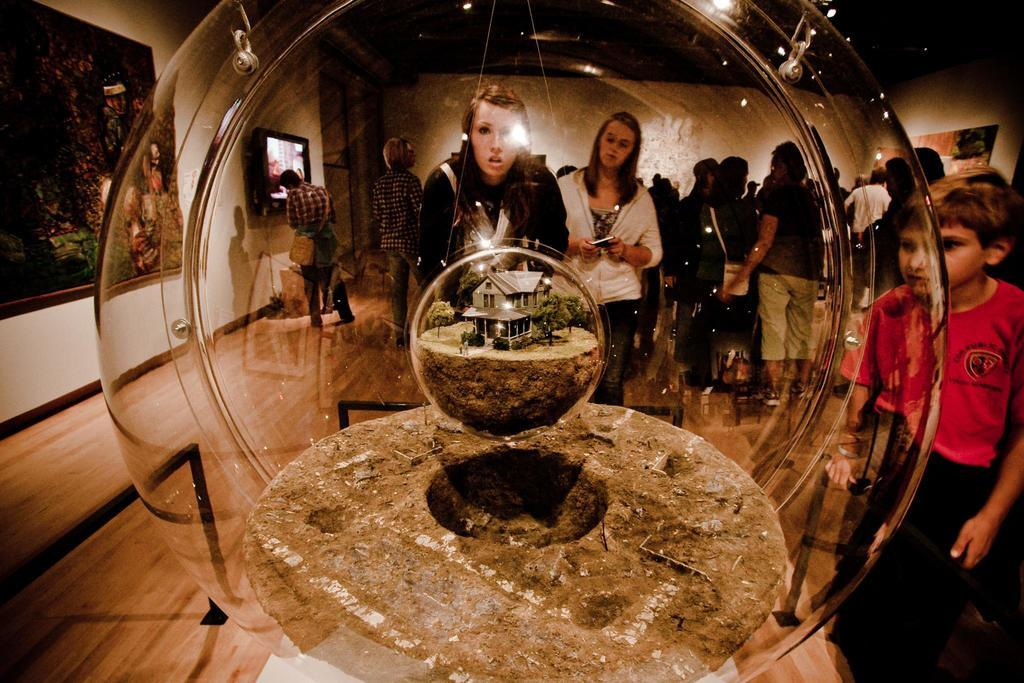What type of structure is visible in the image? There is a house in the image. What can be seen on the ground in the image? Trees are present on the ground in the image. What are the people in the image doing? There is a group of people standing in the image. Where are the people standing? The people are standing on the floor. What can be seen on the walls in the background of the image? There are frames on the walls in the background of the image. What type of screw can be seen being used by the people in the image? There is no screw present in the image; the people are simply standing. What experience are the people in the image having? The facts provided do not give any information about the people's experience, so it cannot be determined from the image. 